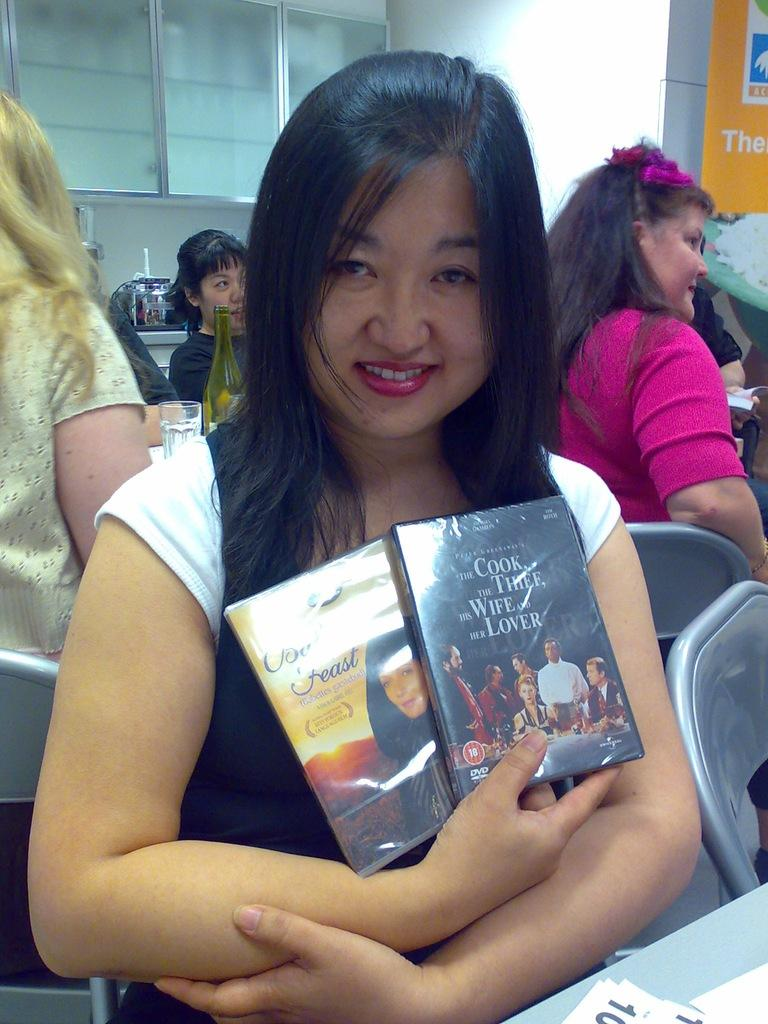<image>
Describe the image concisely. A woman is holding up the DVD called The cook, the thief, his Wife and her lover. 